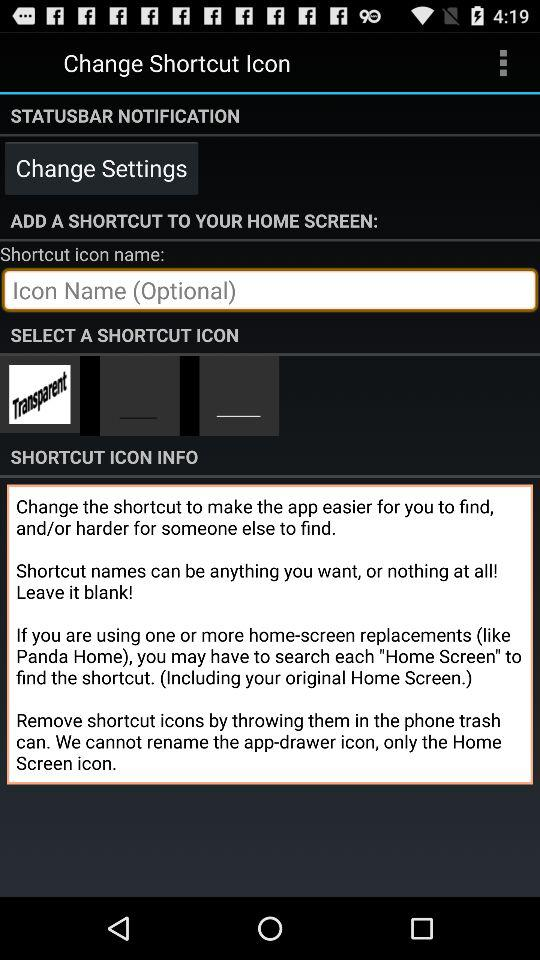Which name is optional to mention? The name that is optional to mention is "Icon Name". 